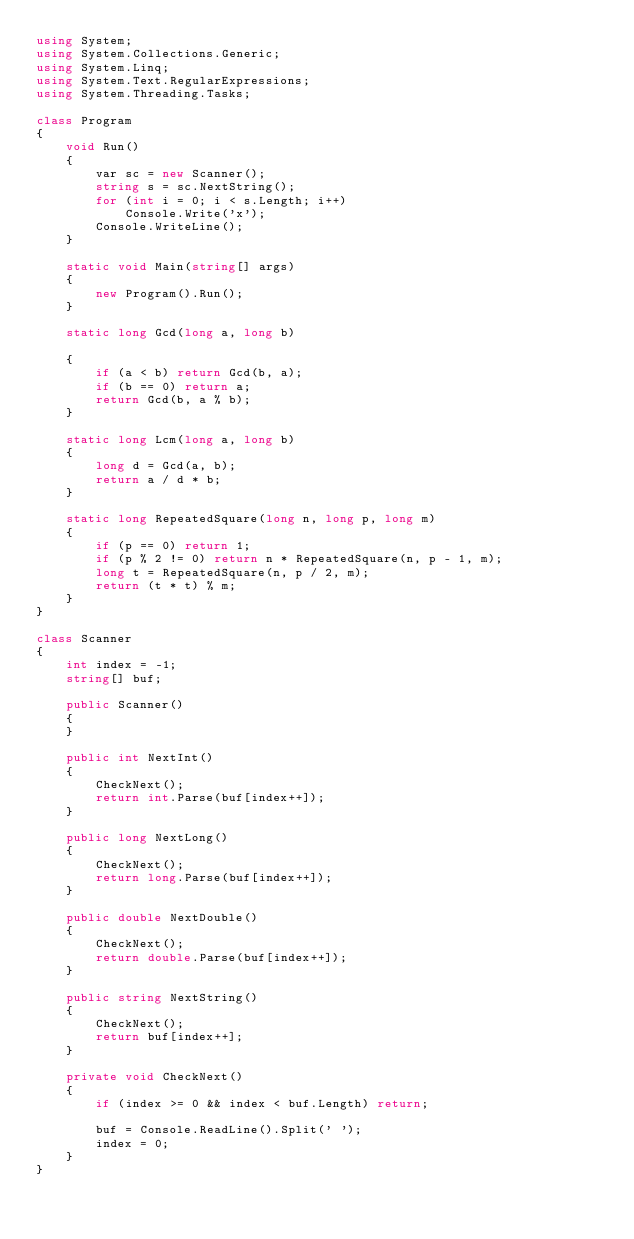Convert code to text. <code><loc_0><loc_0><loc_500><loc_500><_C#_>using System;
using System.Collections.Generic;
using System.Linq;
using System.Text.RegularExpressions;
using System.Threading.Tasks;

class Program
{
    void Run()
    {
        var sc = new Scanner();
        string s = sc.NextString();
        for (int i = 0; i < s.Length; i++)
            Console.Write('x');
        Console.WriteLine();
    }

    static void Main(string[] args)
    {
        new Program().Run();
    }

    static long Gcd(long a, long b)

    {
        if (a < b) return Gcd(b, a);
        if (b == 0) return a;
        return Gcd(b, a % b);
    }

    static long Lcm(long a, long b)
    {
        long d = Gcd(a, b);
        return a / d * b;
    }

    static long RepeatedSquare(long n, long p, long m)
    {
        if (p == 0) return 1;
        if (p % 2 != 0) return n * RepeatedSquare(n, p - 1, m);
        long t = RepeatedSquare(n, p / 2, m);
        return (t * t) % m;
    }
}

class Scanner
{
    int index = -1;
    string[] buf;

    public Scanner()
    {
    }

    public int NextInt()
    {
        CheckNext();
        return int.Parse(buf[index++]);
    }

    public long NextLong()
    {
        CheckNext();
        return long.Parse(buf[index++]);
    }

    public double NextDouble()
    {
        CheckNext();
        return double.Parse(buf[index++]);
    }

    public string NextString()
    {
        CheckNext();
        return buf[index++];
    }

    private void CheckNext()
    {
        if (index >= 0 && index < buf.Length) return;

        buf = Console.ReadLine().Split(' ');
        index = 0;
    }
}
</code> 